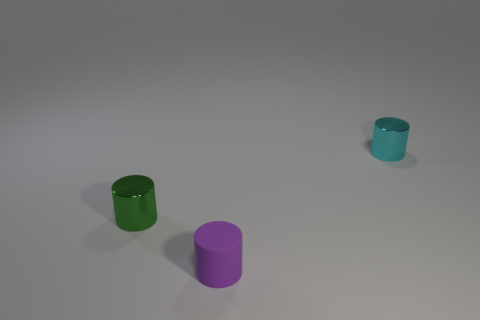Subtract all cyan metallic cylinders. How many cylinders are left? 2 Add 1 yellow matte things. How many objects exist? 4 Add 1 large purple cylinders. How many large purple cylinders exist? 1 Subtract 0 blue cylinders. How many objects are left? 3 Subtract all tiny cyan cylinders. Subtract all small cyan cylinders. How many objects are left? 1 Add 2 purple rubber things. How many purple rubber things are left? 3 